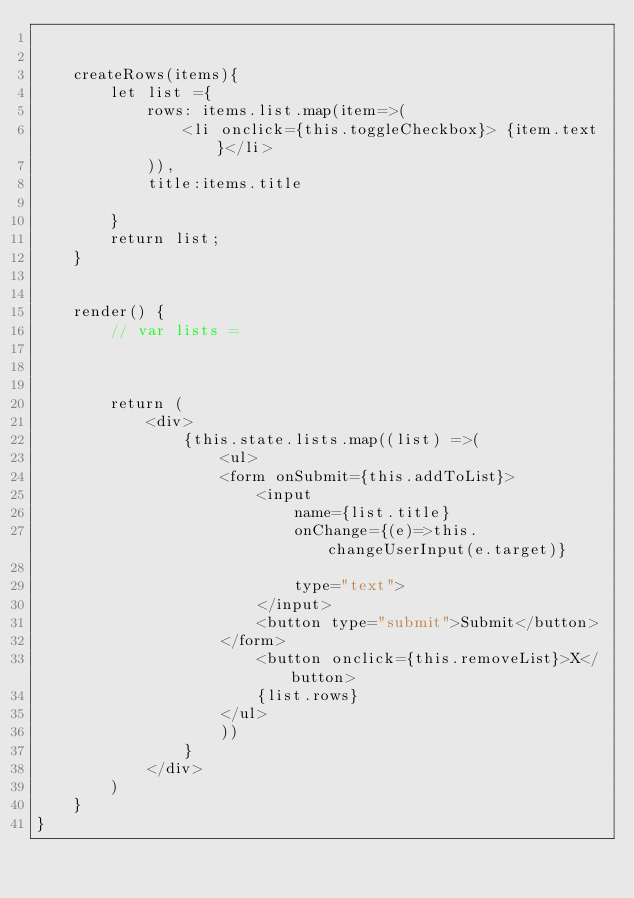<code> <loc_0><loc_0><loc_500><loc_500><_JavaScript_>

    createRows(items){
        let list ={
            rows: items.list.map(item=>(
                <li onclick={this.toggleCheckbox}> {item.text}</li>
            )),
            title:items.title

        }
        return list;
    }

       
    render() {
        // var lists = 

        

        return (
            <div>
                {this.state.lists.map((list) =>(
                    <ul>
                    <form onSubmit={this.addToList}>
                        <input
                            name={list.title}     
                            onChange={(e)=>this.changeUserInput(e.target)}

                            type="text">
                        </input>
                        <button type="submit">Submit</button>
                    </form>
                        <button onclick={this.removeList}>X</button>
                        {list.rows}
                    </ul>
                    ))
                }
            </div>          
        )
    }
}</code> 